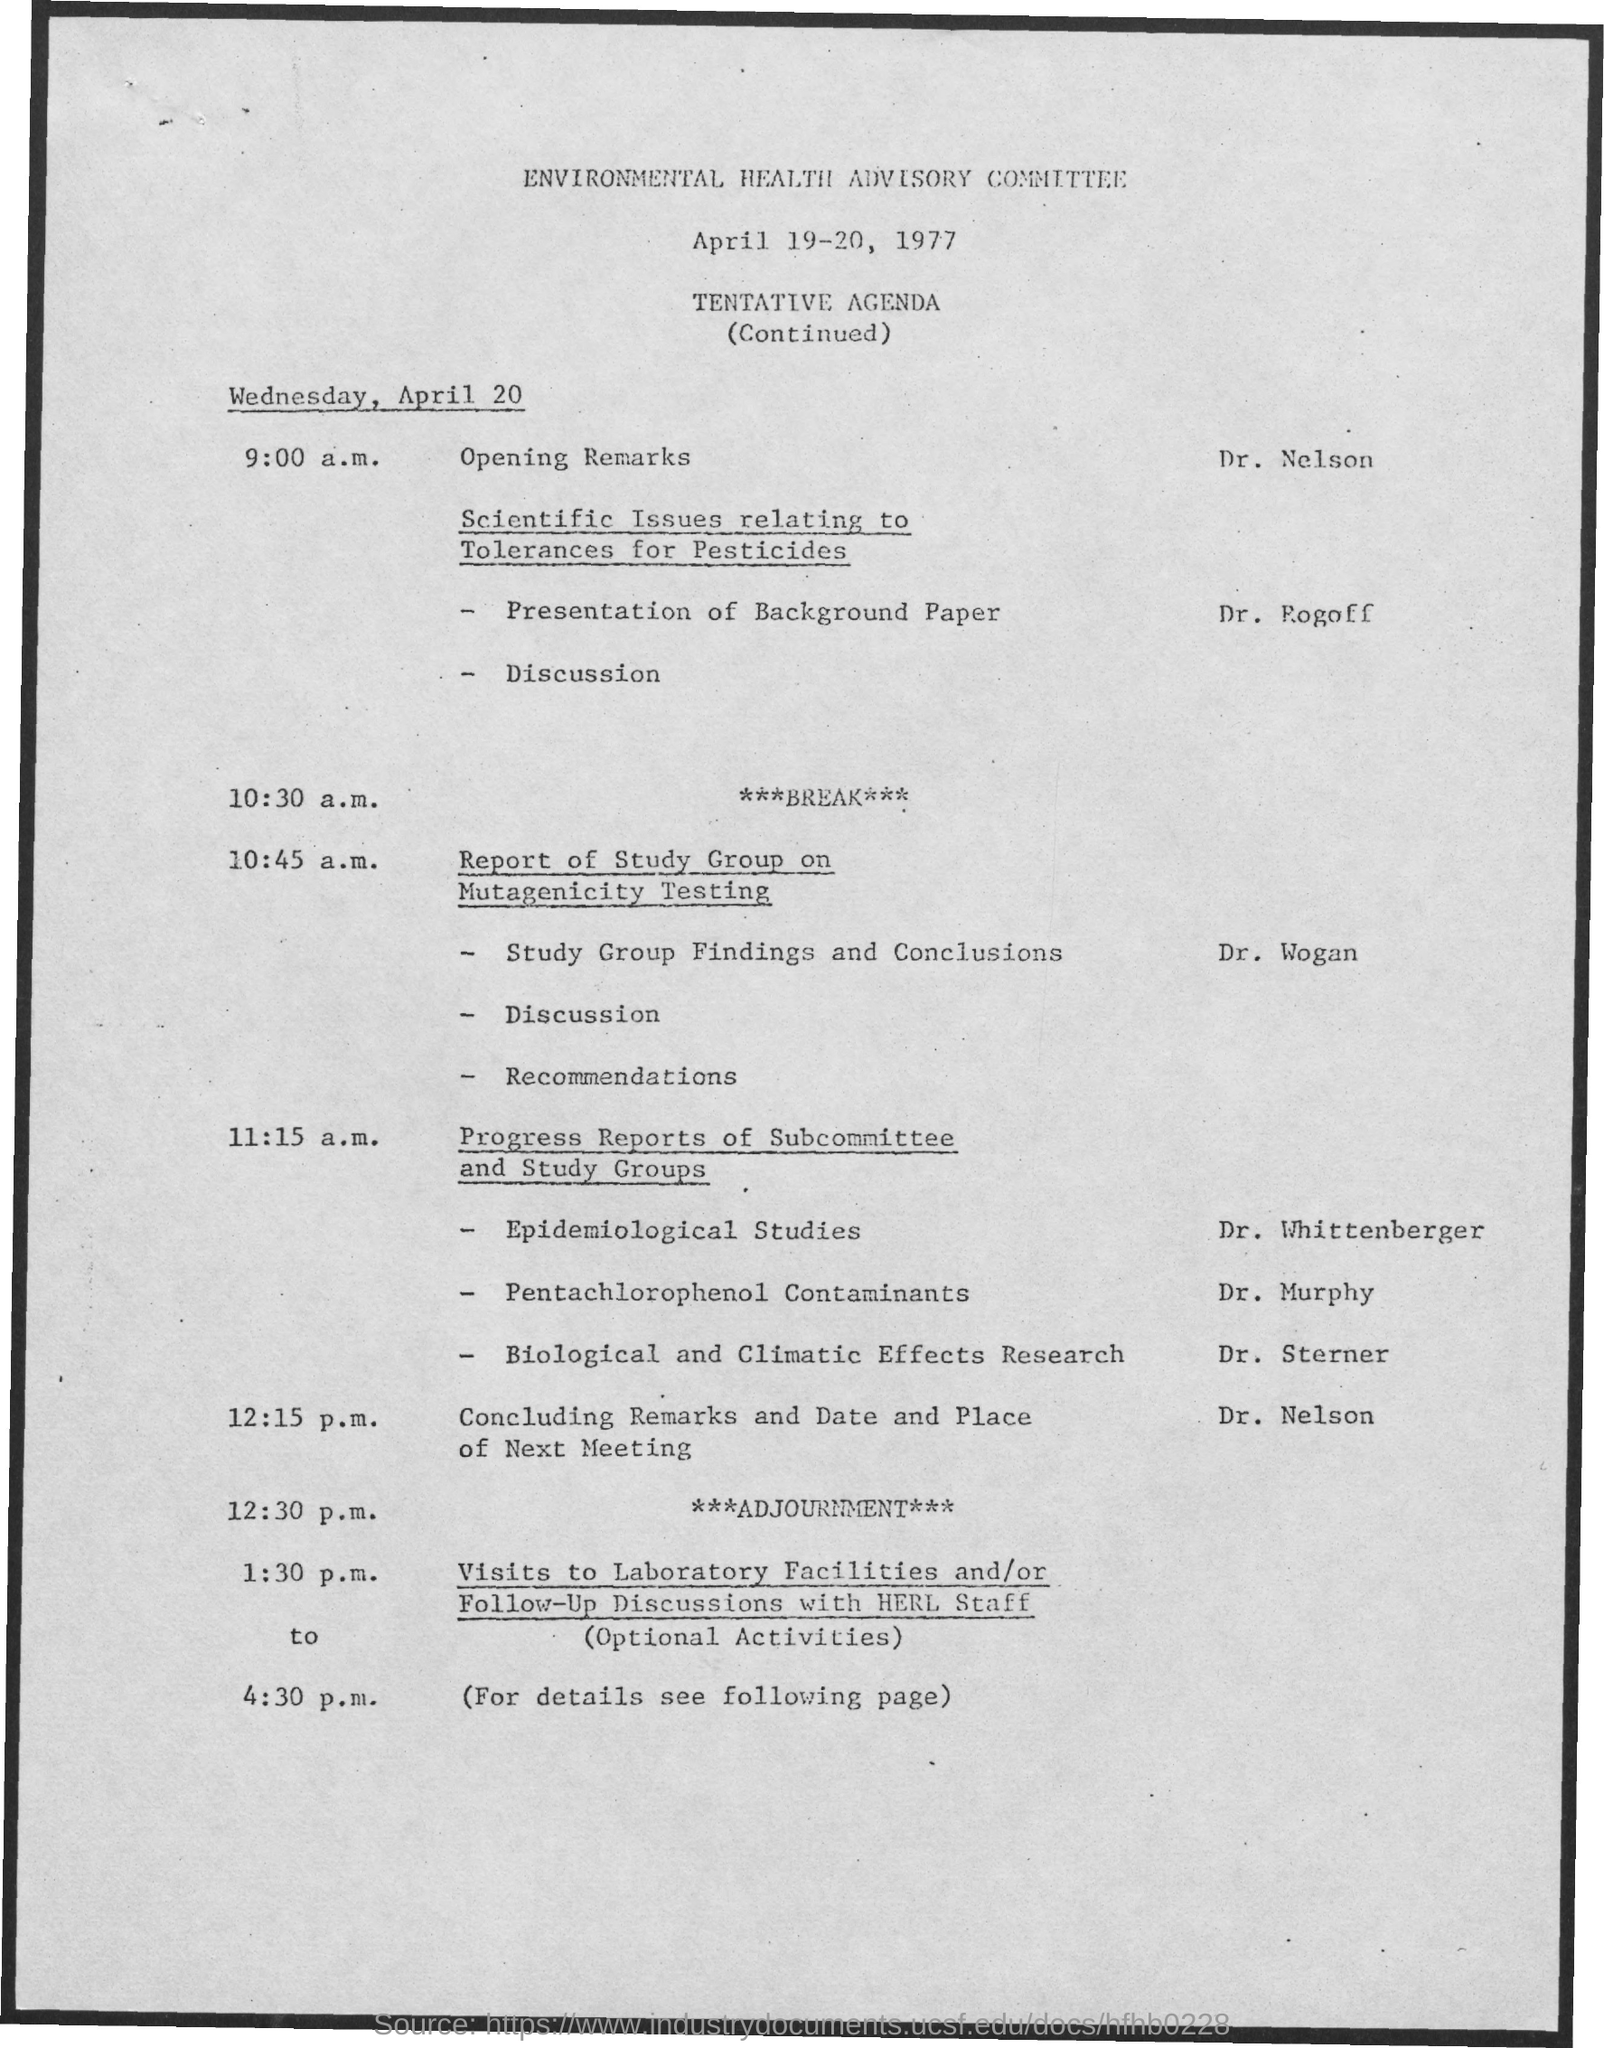Give some essential details in this illustration. The date mentioned in the given page is April 19-20, 1977. At 10:30 a.m. on April 20, the schedule will be as follows: (insert schedule details). At 9:00 a.m. on Wednesday, April 20, the schedule included opening remarks. The Environmental Health Advisory Committee is a committee that has been mentioned. 